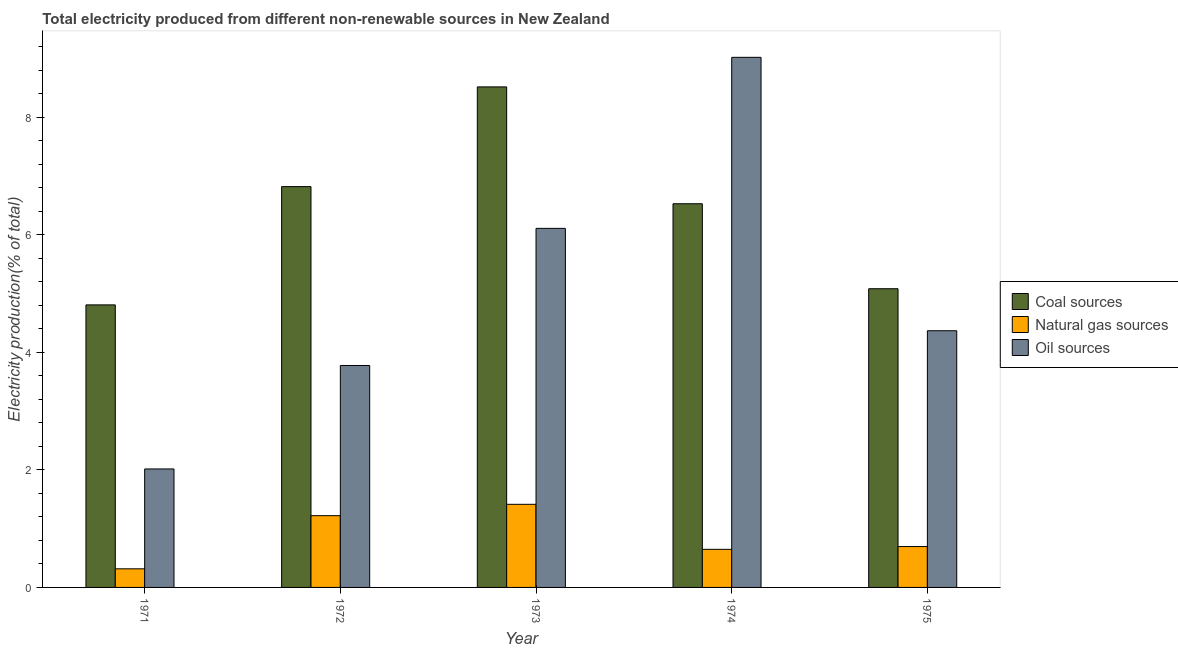What is the label of the 5th group of bars from the left?
Offer a very short reply. 1975. In how many cases, is the number of bars for a given year not equal to the number of legend labels?
Provide a short and direct response. 0. What is the percentage of electricity produced by coal in 1971?
Give a very brief answer. 4.81. Across all years, what is the maximum percentage of electricity produced by natural gas?
Your response must be concise. 1.41. Across all years, what is the minimum percentage of electricity produced by oil sources?
Offer a terse response. 2.02. In which year was the percentage of electricity produced by oil sources maximum?
Offer a very short reply. 1974. What is the total percentage of electricity produced by oil sources in the graph?
Give a very brief answer. 25.29. What is the difference between the percentage of electricity produced by coal in 1971 and that in 1972?
Your answer should be very brief. -2.01. What is the difference between the percentage of electricity produced by coal in 1975 and the percentage of electricity produced by natural gas in 1973?
Give a very brief answer. -3.43. What is the average percentage of electricity produced by oil sources per year?
Your response must be concise. 5.06. What is the ratio of the percentage of electricity produced by natural gas in 1973 to that in 1975?
Your answer should be compact. 2.03. Is the difference between the percentage of electricity produced by coal in 1972 and 1975 greater than the difference between the percentage of electricity produced by natural gas in 1972 and 1975?
Provide a succinct answer. No. What is the difference between the highest and the second highest percentage of electricity produced by oil sources?
Make the answer very short. 2.91. What is the difference between the highest and the lowest percentage of electricity produced by oil sources?
Give a very brief answer. 7. What does the 3rd bar from the left in 1973 represents?
Provide a short and direct response. Oil sources. What does the 1st bar from the right in 1971 represents?
Your response must be concise. Oil sources. Does the graph contain any zero values?
Keep it short and to the point. No. How many legend labels are there?
Provide a short and direct response. 3. What is the title of the graph?
Ensure brevity in your answer.  Total electricity produced from different non-renewable sources in New Zealand. What is the label or title of the X-axis?
Provide a short and direct response. Year. What is the Electricity production(% of total) in Coal sources in 1971?
Make the answer very short. 4.81. What is the Electricity production(% of total) in Natural gas sources in 1971?
Your answer should be very brief. 0.32. What is the Electricity production(% of total) of Oil sources in 1971?
Ensure brevity in your answer.  2.02. What is the Electricity production(% of total) of Coal sources in 1972?
Make the answer very short. 6.82. What is the Electricity production(% of total) of Natural gas sources in 1972?
Provide a succinct answer. 1.22. What is the Electricity production(% of total) of Oil sources in 1972?
Provide a succinct answer. 3.78. What is the Electricity production(% of total) of Coal sources in 1973?
Offer a terse response. 8.52. What is the Electricity production(% of total) of Natural gas sources in 1973?
Provide a succinct answer. 1.41. What is the Electricity production(% of total) of Oil sources in 1973?
Your response must be concise. 6.11. What is the Electricity production(% of total) in Coal sources in 1974?
Make the answer very short. 6.53. What is the Electricity production(% of total) of Natural gas sources in 1974?
Ensure brevity in your answer.  0.65. What is the Electricity production(% of total) of Oil sources in 1974?
Offer a terse response. 9.02. What is the Electricity production(% of total) of Coal sources in 1975?
Provide a succinct answer. 5.08. What is the Electricity production(% of total) in Natural gas sources in 1975?
Offer a terse response. 0.7. What is the Electricity production(% of total) in Oil sources in 1975?
Provide a succinct answer. 4.37. Across all years, what is the maximum Electricity production(% of total) of Coal sources?
Keep it short and to the point. 8.52. Across all years, what is the maximum Electricity production(% of total) in Natural gas sources?
Keep it short and to the point. 1.41. Across all years, what is the maximum Electricity production(% of total) in Oil sources?
Your answer should be compact. 9.02. Across all years, what is the minimum Electricity production(% of total) of Coal sources?
Your answer should be very brief. 4.81. Across all years, what is the minimum Electricity production(% of total) in Natural gas sources?
Give a very brief answer. 0.32. Across all years, what is the minimum Electricity production(% of total) of Oil sources?
Keep it short and to the point. 2.02. What is the total Electricity production(% of total) in Coal sources in the graph?
Offer a very short reply. 31.75. What is the total Electricity production(% of total) in Natural gas sources in the graph?
Your answer should be very brief. 4.29. What is the total Electricity production(% of total) in Oil sources in the graph?
Ensure brevity in your answer.  25.29. What is the difference between the Electricity production(% of total) in Coal sources in 1971 and that in 1972?
Ensure brevity in your answer.  -2.01. What is the difference between the Electricity production(% of total) of Natural gas sources in 1971 and that in 1972?
Offer a terse response. -0.9. What is the difference between the Electricity production(% of total) in Oil sources in 1971 and that in 1972?
Offer a terse response. -1.76. What is the difference between the Electricity production(% of total) of Coal sources in 1971 and that in 1973?
Your answer should be very brief. -3.71. What is the difference between the Electricity production(% of total) of Natural gas sources in 1971 and that in 1973?
Keep it short and to the point. -1.1. What is the difference between the Electricity production(% of total) of Oil sources in 1971 and that in 1973?
Your response must be concise. -4.09. What is the difference between the Electricity production(% of total) in Coal sources in 1971 and that in 1974?
Make the answer very short. -1.72. What is the difference between the Electricity production(% of total) in Natural gas sources in 1971 and that in 1974?
Give a very brief answer. -0.33. What is the difference between the Electricity production(% of total) in Oil sources in 1971 and that in 1974?
Give a very brief answer. -7. What is the difference between the Electricity production(% of total) of Coal sources in 1971 and that in 1975?
Provide a short and direct response. -0.27. What is the difference between the Electricity production(% of total) of Natural gas sources in 1971 and that in 1975?
Offer a very short reply. -0.38. What is the difference between the Electricity production(% of total) of Oil sources in 1971 and that in 1975?
Keep it short and to the point. -2.35. What is the difference between the Electricity production(% of total) of Coal sources in 1972 and that in 1973?
Provide a short and direct response. -1.7. What is the difference between the Electricity production(% of total) of Natural gas sources in 1972 and that in 1973?
Offer a terse response. -0.19. What is the difference between the Electricity production(% of total) in Oil sources in 1972 and that in 1973?
Give a very brief answer. -2.33. What is the difference between the Electricity production(% of total) of Coal sources in 1972 and that in 1974?
Provide a short and direct response. 0.29. What is the difference between the Electricity production(% of total) in Natural gas sources in 1972 and that in 1974?
Ensure brevity in your answer.  0.57. What is the difference between the Electricity production(% of total) of Oil sources in 1972 and that in 1974?
Your answer should be compact. -5.24. What is the difference between the Electricity production(% of total) of Coal sources in 1972 and that in 1975?
Provide a succinct answer. 1.74. What is the difference between the Electricity production(% of total) of Natural gas sources in 1972 and that in 1975?
Your answer should be compact. 0.53. What is the difference between the Electricity production(% of total) in Oil sources in 1972 and that in 1975?
Your response must be concise. -0.59. What is the difference between the Electricity production(% of total) in Coal sources in 1973 and that in 1974?
Make the answer very short. 1.99. What is the difference between the Electricity production(% of total) in Natural gas sources in 1973 and that in 1974?
Your answer should be very brief. 0.77. What is the difference between the Electricity production(% of total) in Oil sources in 1973 and that in 1974?
Offer a very short reply. -2.91. What is the difference between the Electricity production(% of total) in Coal sources in 1973 and that in 1975?
Ensure brevity in your answer.  3.43. What is the difference between the Electricity production(% of total) of Natural gas sources in 1973 and that in 1975?
Your answer should be very brief. 0.72. What is the difference between the Electricity production(% of total) of Oil sources in 1973 and that in 1975?
Your response must be concise. 1.74. What is the difference between the Electricity production(% of total) of Coal sources in 1974 and that in 1975?
Your response must be concise. 1.45. What is the difference between the Electricity production(% of total) in Natural gas sources in 1974 and that in 1975?
Your answer should be very brief. -0.05. What is the difference between the Electricity production(% of total) in Oil sources in 1974 and that in 1975?
Your response must be concise. 4.65. What is the difference between the Electricity production(% of total) of Coal sources in 1971 and the Electricity production(% of total) of Natural gas sources in 1972?
Offer a very short reply. 3.59. What is the difference between the Electricity production(% of total) of Coal sources in 1971 and the Electricity production(% of total) of Oil sources in 1972?
Provide a succinct answer. 1.03. What is the difference between the Electricity production(% of total) in Natural gas sources in 1971 and the Electricity production(% of total) in Oil sources in 1972?
Keep it short and to the point. -3.46. What is the difference between the Electricity production(% of total) of Coal sources in 1971 and the Electricity production(% of total) of Natural gas sources in 1973?
Keep it short and to the point. 3.39. What is the difference between the Electricity production(% of total) in Coal sources in 1971 and the Electricity production(% of total) in Oil sources in 1973?
Provide a succinct answer. -1.3. What is the difference between the Electricity production(% of total) of Natural gas sources in 1971 and the Electricity production(% of total) of Oil sources in 1973?
Give a very brief answer. -5.79. What is the difference between the Electricity production(% of total) of Coal sources in 1971 and the Electricity production(% of total) of Natural gas sources in 1974?
Provide a short and direct response. 4.16. What is the difference between the Electricity production(% of total) of Coal sources in 1971 and the Electricity production(% of total) of Oil sources in 1974?
Ensure brevity in your answer.  -4.21. What is the difference between the Electricity production(% of total) of Natural gas sources in 1971 and the Electricity production(% of total) of Oil sources in 1974?
Offer a very short reply. -8.7. What is the difference between the Electricity production(% of total) of Coal sources in 1971 and the Electricity production(% of total) of Natural gas sources in 1975?
Provide a succinct answer. 4.11. What is the difference between the Electricity production(% of total) of Coal sources in 1971 and the Electricity production(% of total) of Oil sources in 1975?
Keep it short and to the point. 0.44. What is the difference between the Electricity production(% of total) of Natural gas sources in 1971 and the Electricity production(% of total) of Oil sources in 1975?
Provide a succinct answer. -4.05. What is the difference between the Electricity production(% of total) of Coal sources in 1972 and the Electricity production(% of total) of Natural gas sources in 1973?
Make the answer very short. 5.41. What is the difference between the Electricity production(% of total) in Coal sources in 1972 and the Electricity production(% of total) in Oil sources in 1973?
Offer a very short reply. 0.71. What is the difference between the Electricity production(% of total) in Natural gas sources in 1972 and the Electricity production(% of total) in Oil sources in 1973?
Your response must be concise. -4.89. What is the difference between the Electricity production(% of total) of Coal sources in 1972 and the Electricity production(% of total) of Natural gas sources in 1974?
Offer a terse response. 6.17. What is the difference between the Electricity production(% of total) of Coal sources in 1972 and the Electricity production(% of total) of Oil sources in 1974?
Your answer should be very brief. -2.2. What is the difference between the Electricity production(% of total) of Natural gas sources in 1972 and the Electricity production(% of total) of Oil sources in 1974?
Your response must be concise. -7.8. What is the difference between the Electricity production(% of total) in Coal sources in 1972 and the Electricity production(% of total) in Natural gas sources in 1975?
Keep it short and to the point. 6.12. What is the difference between the Electricity production(% of total) of Coal sources in 1972 and the Electricity production(% of total) of Oil sources in 1975?
Keep it short and to the point. 2.45. What is the difference between the Electricity production(% of total) in Natural gas sources in 1972 and the Electricity production(% of total) in Oil sources in 1975?
Make the answer very short. -3.15. What is the difference between the Electricity production(% of total) of Coal sources in 1973 and the Electricity production(% of total) of Natural gas sources in 1974?
Your answer should be very brief. 7.87. What is the difference between the Electricity production(% of total) in Coal sources in 1973 and the Electricity production(% of total) in Oil sources in 1974?
Provide a short and direct response. -0.5. What is the difference between the Electricity production(% of total) of Natural gas sources in 1973 and the Electricity production(% of total) of Oil sources in 1974?
Your response must be concise. -7.6. What is the difference between the Electricity production(% of total) of Coal sources in 1973 and the Electricity production(% of total) of Natural gas sources in 1975?
Your answer should be compact. 7.82. What is the difference between the Electricity production(% of total) in Coal sources in 1973 and the Electricity production(% of total) in Oil sources in 1975?
Ensure brevity in your answer.  4.15. What is the difference between the Electricity production(% of total) of Natural gas sources in 1973 and the Electricity production(% of total) of Oil sources in 1975?
Offer a terse response. -2.95. What is the difference between the Electricity production(% of total) of Coal sources in 1974 and the Electricity production(% of total) of Natural gas sources in 1975?
Offer a terse response. 5.83. What is the difference between the Electricity production(% of total) in Coal sources in 1974 and the Electricity production(% of total) in Oil sources in 1975?
Provide a short and direct response. 2.16. What is the difference between the Electricity production(% of total) of Natural gas sources in 1974 and the Electricity production(% of total) of Oil sources in 1975?
Your answer should be very brief. -3.72. What is the average Electricity production(% of total) in Coal sources per year?
Provide a succinct answer. 6.35. What is the average Electricity production(% of total) in Natural gas sources per year?
Ensure brevity in your answer.  0.86. What is the average Electricity production(% of total) of Oil sources per year?
Offer a terse response. 5.06. In the year 1971, what is the difference between the Electricity production(% of total) in Coal sources and Electricity production(% of total) in Natural gas sources?
Offer a terse response. 4.49. In the year 1971, what is the difference between the Electricity production(% of total) in Coal sources and Electricity production(% of total) in Oil sources?
Offer a terse response. 2.79. In the year 1971, what is the difference between the Electricity production(% of total) of Natural gas sources and Electricity production(% of total) of Oil sources?
Ensure brevity in your answer.  -1.7. In the year 1972, what is the difference between the Electricity production(% of total) in Coal sources and Electricity production(% of total) in Natural gas sources?
Keep it short and to the point. 5.6. In the year 1972, what is the difference between the Electricity production(% of total) of Coal sources and Electricity production(% of total) of Oil sources?
Keep it short and to the point. 3.04. In the year 1972, what is the difference between the Electricity production(% of total) of Natural gas sources and Electricity production(% of total) of Oil sources?
Your answer should be very brief. -2.55. In the year 1973, what is the difference between the Electricity production(% of total) of Coal sources and Electricity production(% of total) of Natural gas sources?
Give a very brief answer. 7.1. In the year 1973, what is the difference between the Electricity production(% of total) of Coal sources and Electricity production(% of total) of Oil sources?
Ensure brevity in your answer.  2.41. In the year 1973, what is the difference between the Electricity production(% of total) in Natural gas sources and Electricity production(% of total) in Oil sources?
Your response must be concise. -4.69. In the year 1974, what is the difference between the Electricity production(% of total) in Coal sources and Electricity production(% of total) in Natural gas sources?
Ensure brevity in your answer.  5.88. In the year 1974, what is the difference between the Electricity production(% of total) of Coal sources and Electricity production(% of total) of Oil sources?
Offer a terse response. -2.49. In the year 1974, what is the difference between the Electricity production(% of total) of Natural gas sources and Electricity production(% of total) of Oil sources?
Make the answer very short. -8.37. In the year 1975, what is the difference between the Electricity production(% of total) of Coal sources and Electricity production(% of total) of Natural gas sources?
Ensure brevity in your answer.  4.39. In the year 1975, what is the difference between the Electricity production(% of total) of Coal sources and Electricity production(% of total) of Oil sources?
Your answer should be very brief. 0.71. In the year 1975, what is the difference between the Electricity production(% of total) in Natural gas sources and Electricity production(% of total) in Oil sources?
Provide a succinct answer. -3.67. What is the ratio of the Electricity production(% of total) of Coal sources in 1971 to that in 1972?
Your response must be concise. 0.7. What is the ratio of the Electricity production(% of total) in Natural gas sources in 1971 to that in 1972?
Ensure brevity in your answer.  0.26. What is the ratio of the Electricity production(% of total) in Oil sources in 1971 to that in 1972?
Provide a succinct answer. 0.53. What is the ratio of the Electricity production(% of total) in Coal sources in 1971 to that in 1973?
Offer a terse response. 0.56. What is the ratio of the Electricity production(% of total) of Natural gas sources in 1971 to that in 1973?
Your answer should be compact. 0.22. What is the ratio of the Electricity production(% of total) in Oil sources in 1971 to that in 1973?
Your answer should be very brief. 0.33. What is the ratio of the Electricity production(% of total) in Coal sources in 1971 to that in 1974?
Offer a terse response. 0.74. What is the ratio of the Electricity production(% of total) in Natural gas sources in 1971 to that in 1974?
Ensure brevity in your answer.  0.49. What is the ratio of the Electricity production(% of total) of Oil sources in 1971 to that in 1974?
Your answer should be compact. 0.22. What is the ratio of the Electricity production(% of total) of Coal sources in 1971 to that in 1975?
Keep it short and to the point. 0.95. What is the ratio of the Electricity production(% of total) in Natural gas sources in 1971 to that in 1975?
Your response must be concise. 0.46. What is the ratio of the Electricity production(% of total) of Oil sources in 1971 to that in 1975?
Keep it short and to the point. 0.46. What is the ratio of the Electricity production(% of total) in Coal sources in 1972 to that in 1973?
Give a very brief answer. 0.8. What is the ratio of the Electricity production(% of total) of Natural gas sources in 1972 to that in 1973?
Provide a short and direct response. 0.86. What is the ratio of the Electricity production(% of total) of Oil sources in 1972 to that in 1973?
Your response must be concise. 0.62. What is the ratio of the Electricity production(% of total) of Coal sources in 1972 to that in 1974?
Give a very brief answer. 1.04. What is the ratio of the Electricity production(% of total) of Natural gas sources in 1972 to that in 1974?
Your answer should be compact. 1.88. What is the ratio of the Electricity production(% of total) of Oil sources in 1972 to that in 1974?
Make the answer very short. 0.42. What is the ratio of the Electricity production(% of total) in Coal sources in 1972 to that in 1975?
Make the answer very short. 1.34. What is the ratio of the Electricity production(% of total) of Natural gas sources in 1972 to that in 1975?
Your answer should be compact. 1.76. What is the ratio of the Electricity production(% of total) in Oil sources in 1972 to that in 1975?
Make the answer very short. 0.86. What is the ratio of the Electricity production(% of total) in Coal sources in 1973 to that in 1974?
Provide a short and direct response. 1.3. What is the ratio of the Electricity production(% of total) of Natural gas sources in 1973 to that in 1974?
Make the answer very short. 2.18. What is the ratio of the Electricity production(% of total) of Oil sources in 1973 to that in 1974?
Give a very brief answer. 0.68. What is the ratio of the Electricity production(% of total) in Coal sources in 1973 to that in 1975?
Keep it short and to the point. 1.68. What is the ratio of the Electricity production(% of total) in Natural gas sources in 1973 to that in 1975?
Offer a very short reply. 2.03. What is the ratio of the Electricity production(% of total) in Oil sources in 1973 to that in 1975?
Provide a short and direct response. 1.4. What is the ratio of the Electricity production(% of total) in Coal sources in 1974 to that in 1975?
Your answer should be compact. 1.28. What is the ratio of the Electricity production(% of total) of Natural gas sources in 1974 to that in 1975?
Ensure brevity in your answer.  0.93. What is the ratio of the Electricity production(% of total) in Oil sources in 1974 to that in 1975?
Provide a short and direct response. 2.07. What is the difference between the highest and the second highest Electricity production(% of total) in Coal sources?
Provide a short and direct response. 1.7. What is the difference between the highest and the second highest Electricity production(% of total) in Natural gas sources?
Ensure brevity in your answer.  0.19. What is the difference between the highest and the second highest Electricity production(% of total) in Oil sources?
Offer a very short reply. 2.91. What is the difference between the highest and the lowest Electricity production(% of total) of Coal sources?
Keep it short and to the point. 3.71. What is the difference between the highest and the lowest Electricity production(% of total) in Natural gas sources?
Your response must be concise. 1.1. What is the difference between the highest and the lowest Electricity production(% of total) in Oil sources?
Provide a short and direct response. 7. 